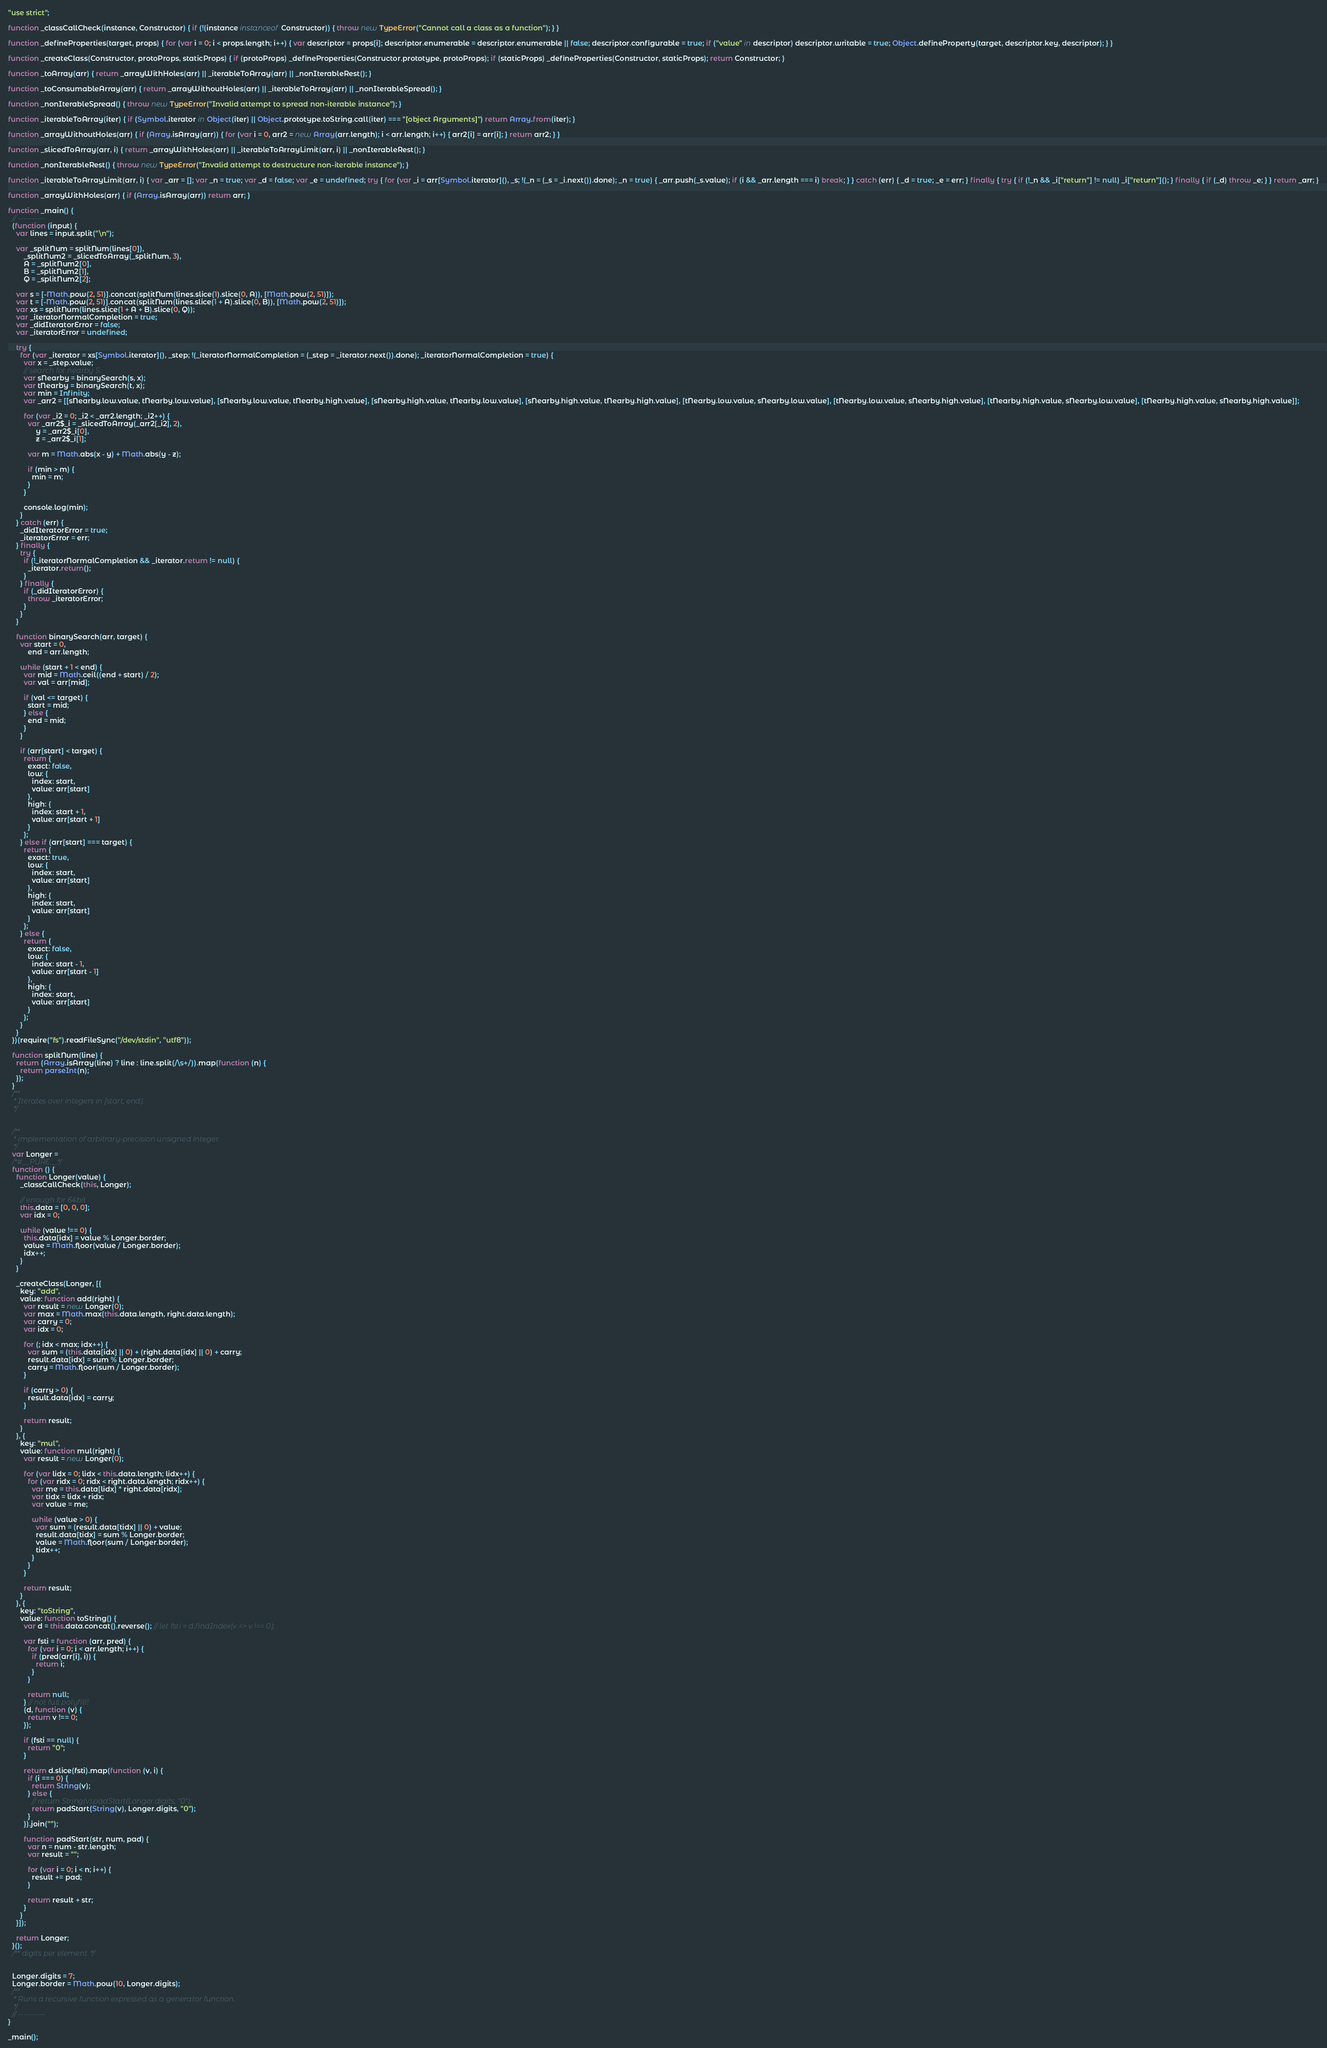<code> <loc_0><loc_0><loc_500><loc_500><_JavaScript_>"use strict";

function _classCallCheck(instance, Constructor) { if (!(instance instanceof Constructor)) { throw new TypeError("Cannot call a class as a function"); } }

function _defineProperties(target, props) { for (var i = 0; i < props.length; i++) { var descriptor = props[i]; descriptor.enumerable = descriptor.enumerable || false; descriptor.configurable = true; if ("value" in descriptor) descriptor.writable = true; Object.defineProperty(target, descriptor.key, descriptor); } }

function _createClass(Constructor, protoProps, staticProps) { if (protoProps) _defineProperties(Constructor.prototype, protoProps); if (staticProps) _defineProperties(Constructor, staticProps); return Constructor; }

function _toArray(arr) { return _arrayWithHoles(arr) || _iterableToArray(arr) || _nonIterableRest(); }

function _toConsumableArray(arr) { return _arrayWithoutHoles(arr) || _iterableToArray(arr) || _nonIterableSpread(); }

function _nonIterableSpread() { throw new TypeError("Invalid attempt to spread non-iterable instance"); }

function _iterableToArray(iter) { if (Symbol.iterator in Object(iter) || Object.prototype.toString.call(iter) === "[object Arguments]") return Array.from(iter); }

function _arrayWithoutHoles(arr) { if (Array.isArray(arr)) { for (var i = 0, arr2 = new Array(arr.length); i < arr.length; i++) { arr2[i] = arr[i]; } return arr2; } }

function _slicedToArray(arr, i) { return _arrayWithHoles(arr) || _iterableToArrayLimit(arr, i) || _nonIterableRest(); }

function _nonIterableRest() { throw new TypeError("Invalid attempt to destructure non-iterable instance"); }

function _iterableToArrayLimit(arr, i) { var _arr = []; var _n = true; var _d = false; var _e = undefined; try { for (var _i = arr[Symbol.iterator](), _s; !(_n = (_s = _i.next()).done); _n = true) { _arr.push(_s.value); if (i && _arr.length === i) break; } } catch (err) { _d = true; _e = err; } finally { try { if (!_n && _i["return"] != null) _i["return"](); } finally { if (_d) throw _e; } } return _arr; }

function _arrayWithHoles(arr) { if (Array.isArray(arr)) return arr; }

function _main() {
  // ----------
  (function (input) {
    var lines = input.split("\n");

    var _splitNum = splitNum(lines[0]),
        _splitNum2 = _slicedToArray(_splitNum, 3),
        A = _splitNum2[0],
        B = _splitNum2[1],
        Q = _splitNum2[2];

    var s = [-Math.pow(2, 51)].concat(splitNum(lines.slice(1).slice(0, A)), [Math.pow(2, 51)]);
    var t = [-Math.pow(2, 51)].concat(splitNum(lines.slice(1 + A).slice(0, B)), [Math.pow(2, 51)]);
    var xs = splitNum(lines.slice(1 + A + B).slice(0, Q));
    var _iteratorNormalCompletion = true;
    var _didIteratorError = false;
    var _iteratorError = undefined;

    try {
      for (var _iterator = xs[Symbol.iterator](), _step; !(_iteratorNormalCompletion = (_step = _iterator.next()).done); _iteratorNormalCompletion = true) {
        var x = _step.value;
        // search for nearby S.
        var sNearby = binarySearch(s, x);
        var tNearby = binarySearch(t, x);
        var min = Infinity;
        var _arr2 = [[sNearby.low.value, tNearby.low.value], [sNearby.low.value, tNearby.high.value], [sNearby.high.value, tNearby.low.value], [sNearby.high.value, tNearby.high.value], [tNearby.low.value, sNearby.low.value], [tNearby.low.value, sNearby.high.value], [tNearby.high.value, sNearby.low.value], [tNearby.high.value, sNearby.high.value]];

        for (var _i2 = 0; _i2 < _arr2.length; _i2++) {
          var _arr2$_i = _slicedToArray(_arr2[_i2], 2),
              y = _arr2$_i[0],
              z = _arr2$_i[1];

          var m = Math.abs(x - y) + Math.abs(y - z);

          if (min > m) {
            min = m;
          }
        }

        console.log(min);
      }
    } catch (err) {
      _didIteratorError = true;
      _iteratorError = err;
    } finally {
      try {
        if (!_iteratorNormalCompletion && _iterator.return != null) {
          _iterator.return();
        }
      } finally {
        if (_didIteratorError) {
          throw _iteratorError;
        }
      }
    }

    function binarySearch(arr, target) {
      var start = 0,
          end = arr.length;

      while (start + 1 < end) {
        var mid = Math.ceil((end + start) / 2);
        var val = arr[mid];

        if (val <= target) {
          start = mid;
        } else {
          end = mid;
        }
      }

      if (arr[start] < target) {
        return {
          exact: false,
          low: {
            index: start,
            value: arr[start]
          },
          high: {
            index: start + 1,
            value: arr[start + 1]
          }
        };
      } else if (arr[start] === target) {
        return {
          exact: true,
          low: {
            index: start,
            value: arr[start]
          },
          high: {
            index: start,
            value: arr[start]
          }
        };
      } else {
        return {
          exact: false,
          low: {
            index: start - 1,
            value: arr[start - 1]
          },
          high: {
            index: start,
            value: arr[start]
          }
        };
      }
    }
  })(require("fs").readFileSync("/dev/stdin", "utf8"));

  function splitNum(line) {
    return (Array.isArray(line) ? line : line.split(/\s+/)).map(function (n) {
      return parseInt(n);
    });
  }
  /**
   * Iterates over integers in [start, end).
   */


  /**
   * implementation of arbitrary-precision unsigned integer.
   */
  var Longer =
  /*#__PURE__*/
  function () {
    function Longer(value) {
      _classCallCheck(this, Longer);

      // enough for 64bit
      this.data = [0, 0, 0];
      var idx = 0;

      while (value !== 0) {
        this.data[idx] = value % Longer.border;
        value = Math.floor(value / Longer.border);
        idx++;
      }
    }

    _createClass(Longer, [{
      key: "add",
      value: function add(right) {
        var result = new Longer(0);
        var max = Math.max(this.data.length, right.data.length);
        var carry = 0;
        var idx = 0;

        for (; idx < max; idx++) {
          var sum = (this.data[idx] || 0) + (right.data[idx] || 0) + carry;
          result.data[idx] = sum % Longer.border;
          carry = Math.floor(sum / Longer.border);
        }

        if (carry > 0) {
          result.data[idx] = carry;
        }

        return result;
      }
    }, {
      key: "mul",
      value: function mul(right) {
        var result = new Longer(0);

        for (var lidx = 0; lidx < this.data.length; lidx++) {
          for (var ridx = 0; ridx < right.data.length; ridx++) {
            var me = this.data[lidx] * right.data[ridx];
            var tidx = lidx + ridx;
            var value = me;

            while (value > 0) {
              var sum = (result.data[tidx] || 0) + value;
              result.data[tidx] = sum % Longer.border;
              value = Math.floor(sum / Longer.border);
              tidx++;
            }
          }
        }

        return result;
      }
    }, {
      key: "toString",
      value: function toString() {
        var d = this.data.concat().reverse(); // let fsti = d.findIndex(v => v !== 0);

        var fsti = function (arr, pred) {
          for (var i = 0; i < arr.length; i++) {
            if (pred(arr[i], i)) {
              return i;
            }
          }

          return null;
        } // not full polyfill!
        (d, function (v) {
          return v !== 0;
        });

        if (fsti == null) {
          return "0";
        }

        return d.slice(fsti).map(function (v, i) {
          if (i === 0) {
            return String(v);
          } else {
            // return String(v).padStart(Longer.digits, "0");
            return padStart(String(v), Longer.digits, "0");
          }
        }).join("");

        function padStart(str, num, pad) {
          var n = num - str.length;
          var result = "";

          for (var i = 0; i < n; i++) {
            result += pad;
          }

          return result + str;
        }
      }
    }]);

    return Longer;
  }();
  /** digits per element. */


  Longer.digits = 7;
  Longer.border = Math.pow(10, Longer.digits);
  /**
   * Runs a recursive function expressed as a generator function.
   */
  // ----------
}

_main();
</code> 